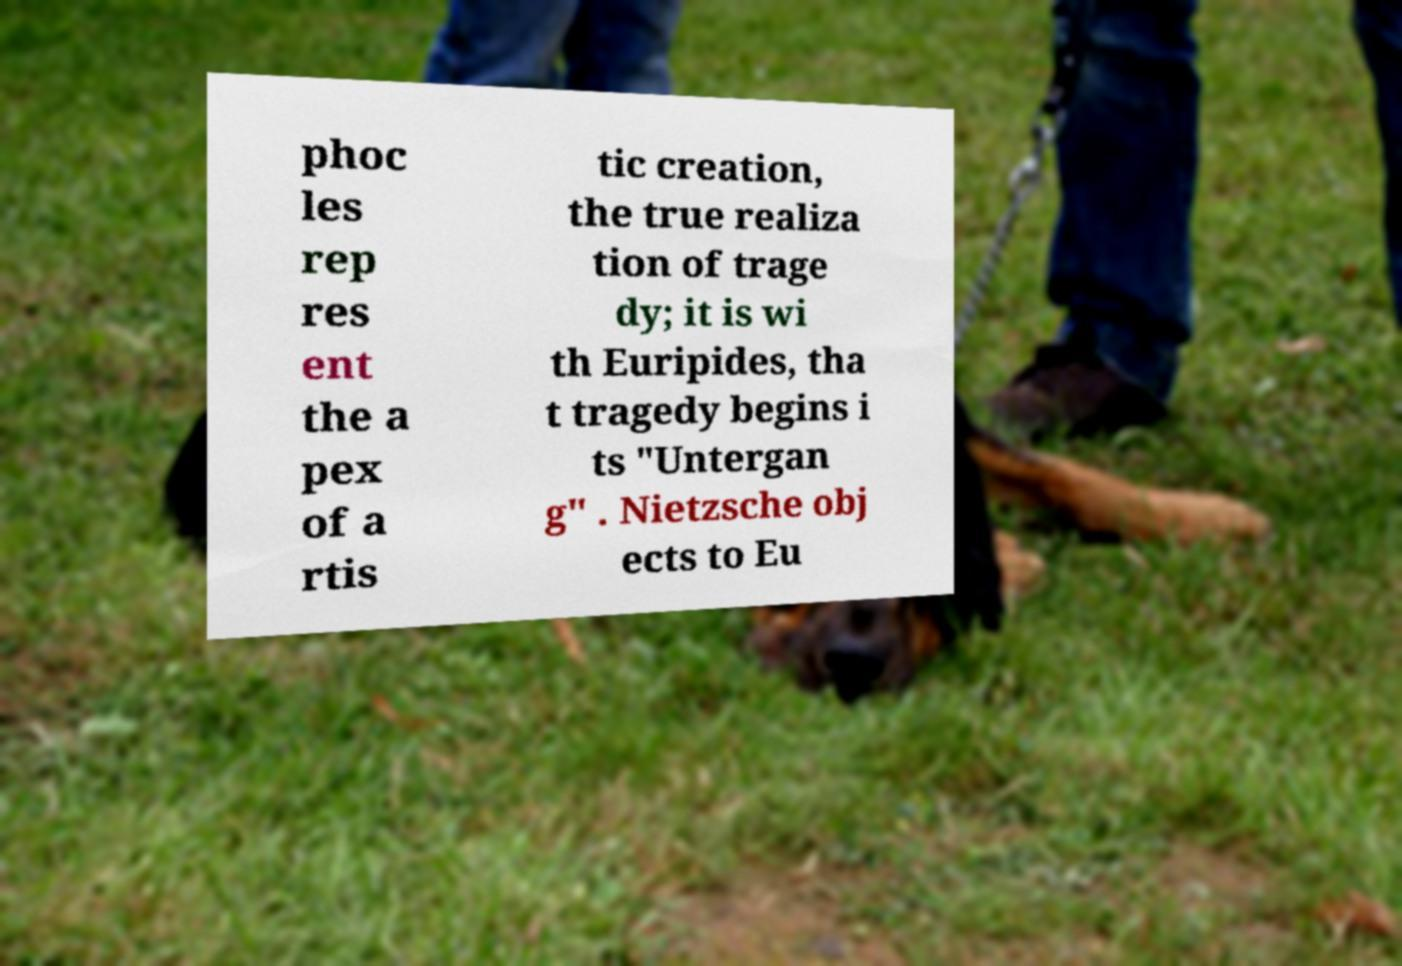Could you assist in decoding the text presented in this image and type it out clearly? phoc les rep res ent the a pex of a rtis tic creation, the true realiza tion of trage dy; it is wi th Euripides, tha t tragedy begins i ts "Untergan g" . Nietzsche obj ects to Eu 